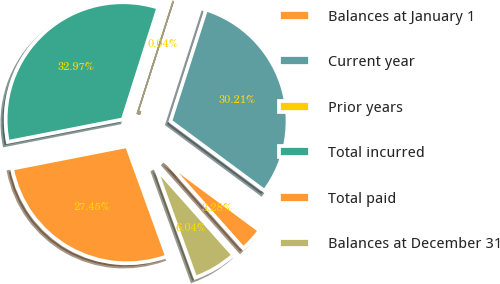Convert chart to OTSL. <chart><loc_0><loc_0><loc_500><loc_500><pie_chart><fcel>Balances at January 1<fcel>Current year<fcel>Prior years<fcel>Total incurred<fcel>Total paid<fcel>Balances at December 31<nl><fcel>3.28%<fcel>30.21%<fcel>0.04%<fcel>32.97%<fcel>27.45%<fcel>6.04%<nl></chart> 